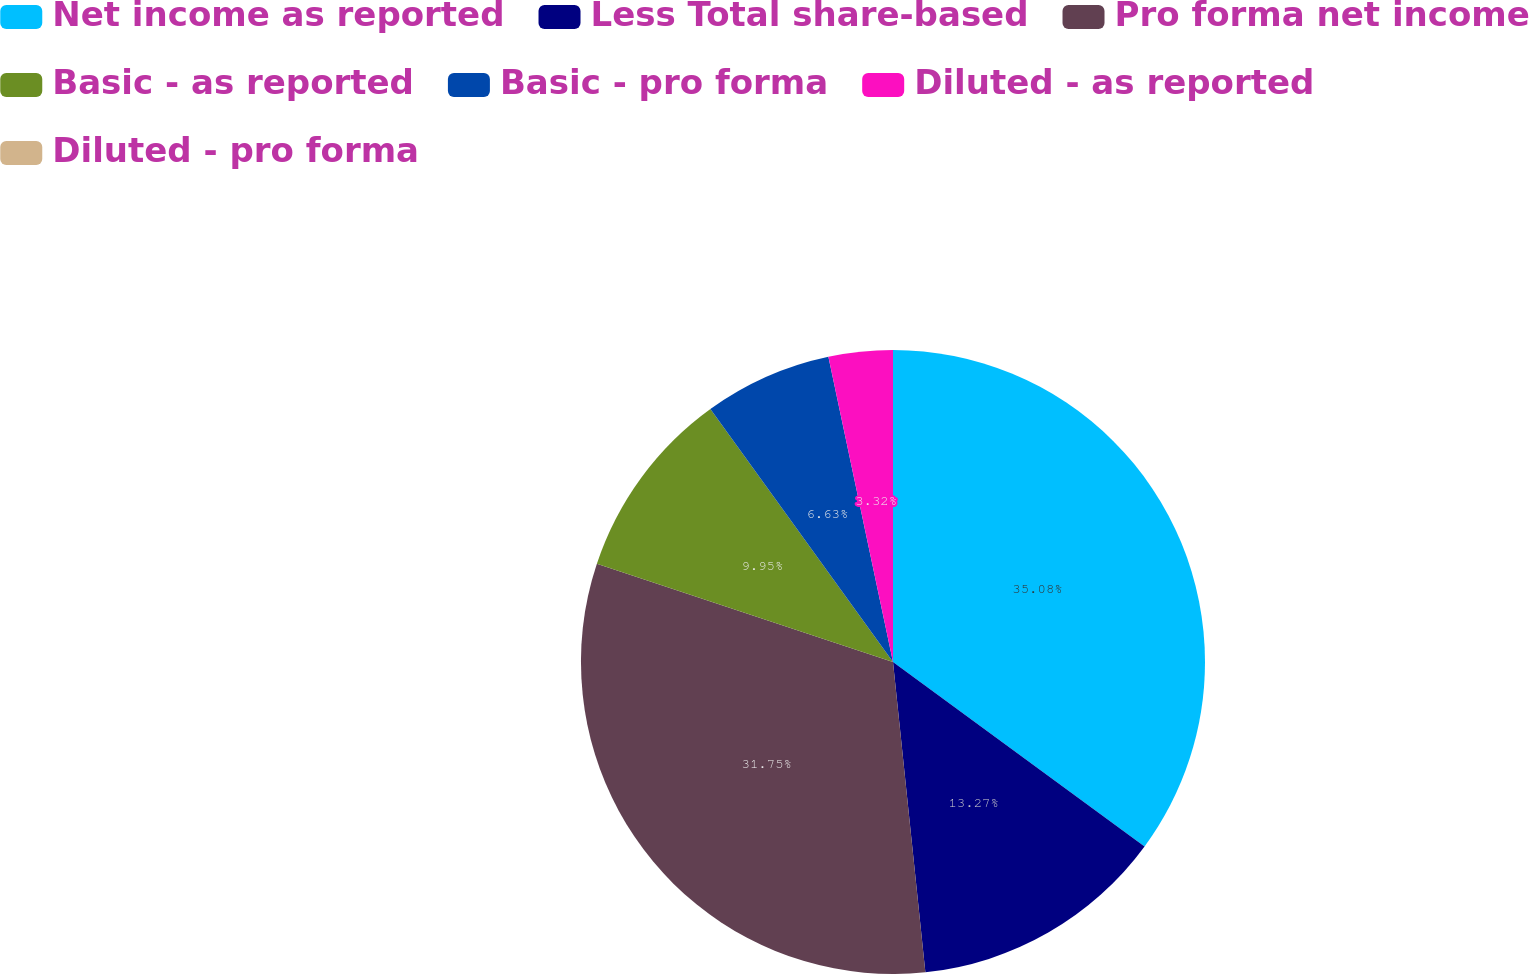Convert chart. <chart><loc_0><loc_0><loc_500><loc_500><pie_chart><fcel>Net income as reported<fcel>Less Total share-based<fcel>Pro forma net income<fcel>Basic - as reported<fcel>Basic - pro forma<fcel>Diluted - as reported<fcel>Diluted - pro forma<nl><fcel>35.07%<fcel>13.27%<fcel>31.75%<fcel>9.95%<fcel>6.63%<fcel>3.32%<fcel>0.0%<nl></chart> 